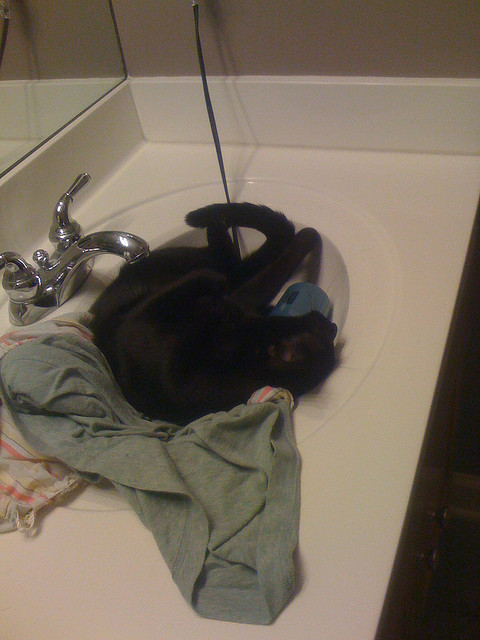Describe the lighting and ambiance in the image. The lighting in the image appears to be relatively dim, giving a warm and cozy ambiance to the scene. The light source seems to be natural light filtering in from a nearby window. What other actions can a cat perform in a sink like this one? A cat in a sink like this one might engage in various activities such as playing with running water from the faucet, curling up and sleeping, or grooming itself. The cool, smooth surface of the sink can be intriguing and enjoyable for cats, especially during hot weather. Imagine if the sink was a magical portal. What adventures could the cat embark on? If the sink were a magical portal, the cat could embark on incredible adventures in far-off lands or fantastical realms. Perhaps the cat jumps into the portal and finds itself in a lush, enchanted forest filled with talking animals and magical creatures. It could wander through ancient ruins, uncovering hidden treasures and making feline friends along the way. The sink could lead to an underwater kingdom where the cat can swim with colorful fish and participate in aquatic adventures. The possibilities are endless, and each journey would be as exciting and unpredictable as the cat's curious nature. 